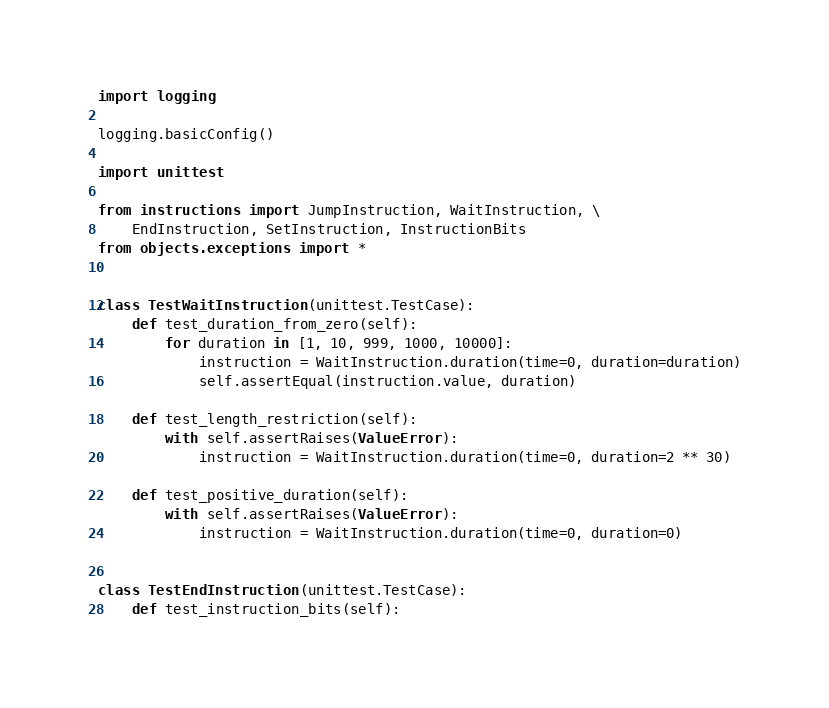Convert code to text. <code><loc_0><loc_0><loc_500><loc_500><_Python_>import logging

logging.basicConfig()

import unittest

from instructions import JumpInstruction, WaitInstruction, \
    EndInstruction, SetInstruction, InstructionBits
from objects.exceptions import *


class TestWaitInstruction(unittest.TestCase):
    def test_duration_from_zero(self):
        for duration in [1, 10, 999, 1000, 10000]:
            instruction = WaitInstruction.duration(time=0, duration=duration)
            self.assertEqual(instruction.value, duration)

    def test_length_restriction(self):
        with self.assertRaises(ValueError):
            instruction = WaitInstruction.duration(time=0, duration=2 ** 30)

    def test_positive_duration(self):
        with self.assertRaises(ValueError):
            instruction = WaitInstruction.duration(time=0, duration=0)


class TestEndInstruction(unittest.TestCase):
    def test_instruction_bits(self):</code> 